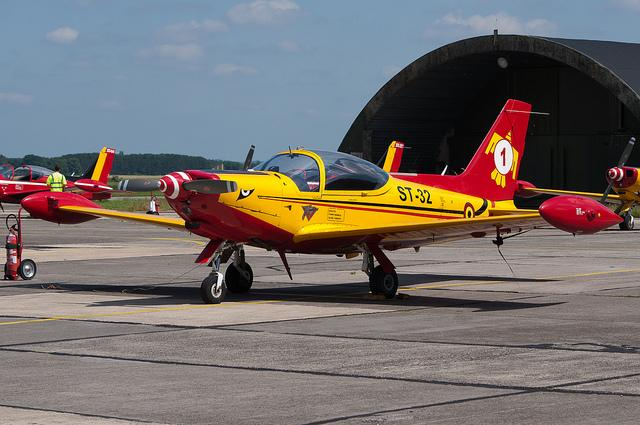What is the purpose of the black structure? Please explain your reasoning. house planes. You store planes in the hanger. 